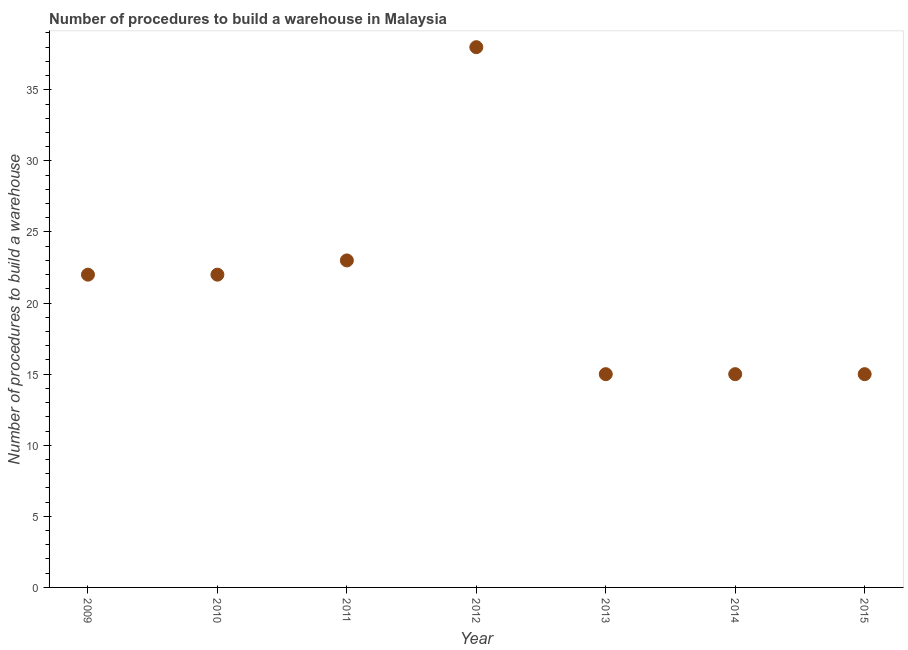What is the number of procedures to build a warehouse in 2011?
Give a very brief answer. 23. Across all years, what is the maximum number of procedures to build a warehouse?
Give a very brief answer. 38. Across all years, what is the minimum number of procedures to build a warehouse?
Your response must be concise. 15. What is the sum of the number of procedures to build a warehouse?
Provide a succinct answer. 150. What is the difference between the number of procedures to build a warehouse in 2010 and 2014?
Give a very brief answer. 7. What is the average number of procedures to build a warehouse per year?
Your answer should be compact. 21.43. What is the median number of procedures to build a warehouse?
Offer a terse response. 22. In how many years, is the number of procedures to build a warehouse greater than 5 ?
Your answer should be compact. 7. Do a majority of the years between 2015 and 2010 (inclusive) have number of procedures to build a warehouse greater than 28 ?
Provide a succinct answer. Yes. What is the ratio of the number of procedures to build a warehouse in 2010 to that in 2014?
Your answer should be compact. 1.47. Is the sum of the number of procedures to build a warehouse in 2011 and 2012 greater than the maximum number of procedures to build a warehouse across all years?
Give a very brief answer. Yes. What is the difference between the highest and the lowest number of procedures to build a warehouse?
Make the answer very short. 23. Does the graph contain any zero values?
Provide a succinct answer. No. What is the title of the graph?
Your response must be concise. Number of procedures to build a warehouse in Malaysia. What is the label or title of the X-axis?
Give a very brief answer. Year. What is the label or title of the Y-axis?
Provide a succinct answer. Number of procedures to build a warehouse. What is the Number of procedures to build a warehouse in 2013?
Offer a terse response. 15. What is the Number of procedures to build a warehouse in 2014?
Make the answer very short. 15. What is the Number of procedures to build a warehouse in 2015?
Keep it short and to the point. 15. What is the difference between the Number of procedures to build a warehouse in 2009 and 2010?
Provide a succinct answer. 0. What is the difference between the Number of procedures to build a warehouse in 2009 and 2012?
Your response must be concise. -16. What is the difference between the Number of procedures to build a warehouse in 2009 and 2013?
Your response must be concise. 7. What is the difference between the Number of procedures to build a warehouse in 2009 and 2014?
Give a very brief answer. 7. What is the difference between the Number of procedures to build a warehouse in 2010 and 2011?
Keep it short and to the point. -1. What is the difference between the Number of procedures to build a warehouse in 2010 and 2015?
Provide a succinct answer. 7. What is the difference between the Number of procedures to build a warehouse in 2011 and 2013?
Provide a short and direct response. 8. What is the difference between the Number of procedures to build a warehouse in 2012 and 2014?
Provide a short and direct response. 23. What is the difference between the Number of procedures to build a warehouse in 2012 and 2015?
Ensure brevity in your answer.  23. What is the difference between the Number of procedures to build a warehouse in 2013 and 2014?
Keep it short and to the point. 0. What is the difference between the Number of procedures to build a warehouse in 2013 and 2015?
Your response must be concise. 0. What is the ratio of the Number of procedures to build a warehouse in 2009 to that in 2011?
Ensure brevity in your answer.  0.96. What is the ratio of the Number of procedures to build a warehouse in 2009 to that in 2012?
Your response must be concise. 0.58. What is the ratio of the Number of procedures to build a warehouse in 2009 to that in 2013?
Your response must be concise. 1.47. What is the ratio of the Number of procedures to build a warehouse in 2009 to that in 2014?
Ensure brevity in your answer.  1.47. What is the ratio of the Number of procedures to build a warehouse in 2009 to that in 2015?
Your answer should be very brief. 1.47. What is the ratio of the Number of procedures to build a warehouse in 2010 to that in 2012?
Your answer should be very brief. 0.58. What is the ratio of the Number of procedures to build a warehouse in 2010 to that in 2013?
Offer a very short reply. 1.47. What is the ratio of the Number of procedures to build a warehouse in 2010 to that in 2014?
Keep it short and to the point. 1.47. What is the ratio of the Number of procedures to build a warehouse in 2010 to that in 2015?
Your answer should be very brief. 1.47. What is the ratio of the Number of procedures to build a warehouse in 2011 to that in 2012?
Provide a succinct answer. 0.6. What is the ratio of the Number of procedures to build a warehouse in 2011 to that in 2013?
Your answer should be compact. 1.53. What is the ratio of the Number of procedures to build a warehouse in 2011 to that in 2014?
Keep it short and to the point. 1.53. What is the ratio of the Number of procedures to build a warehouse in 2011 to that in 2015?
Your response must be concise. 1.53. What is the ratio of the Number of procedures to build a warehouse in 2012 to that in 2013?
Provide a succinct answer. 2.53. What is the ratio of the Number of procedures to build a warehouse in 2012 to that in 2014?
Provide a short and direct response. 2.53. What is the ratio of the Number of procedures to build a warehouse in 2012 to that in 2015?
Offer a very short reply. 2.53. 